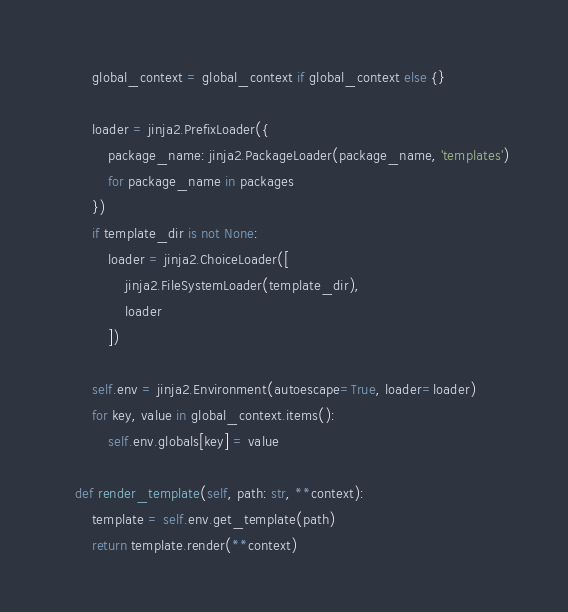<code> <loc_0><loc_0><loc_500><loc_500><_Python_>        global_context = global_context if global_context else {}

        loader = jinja2.PrefixLoader({
            package_name: jinja2.PackageLoader(package_name, 'templates')
            for package_name in packages
        })
        if template_dir is not None:
            loader = jinja2.ChoiceLoader([
                jinja2.FileSystemLoader(template_dir),
                loader
            ])

        self.env = jinja2.Environment(autoescape=True, loader=loader)
        for key, value in global_context.items():
            self.env.globals[key] = value

    def render_template(self, path: str, **context):
        template = self.env.get_template(path)
        return template.render(**context)
</code> 